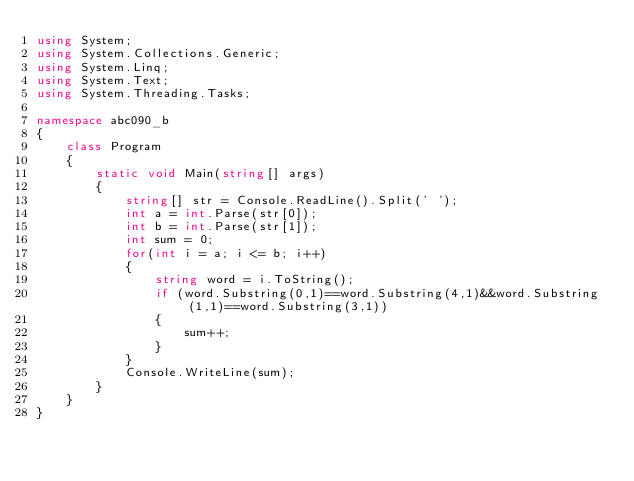<code> <loc_0><loc_0><loc_500><loc_500><_C#_>using System;
using System.Collections.Generic;
using System.Linq;
using System.Text;
using System.Threading.Tasks;

namespace abc090_b
{
    class Program
    {
        static void Main(string[] args)
        {
            string[] str = Console.ReadLine().Split(' ');
            int a = int.Parse(str[0]);
            int b = int.Parse(str[1]);
            int sum = 0;
            for(int i = a; i <= b; i++)
            {
                string word = i.ToString();
                if (word.Substring(0,1)==word.Substring(4,1)&&word.Substring(1,1)==word.Substring(3,1))
                {
                    sum++;
                }
            }
            Console.WriteLine(sum);
        }
    }
}
</code> 